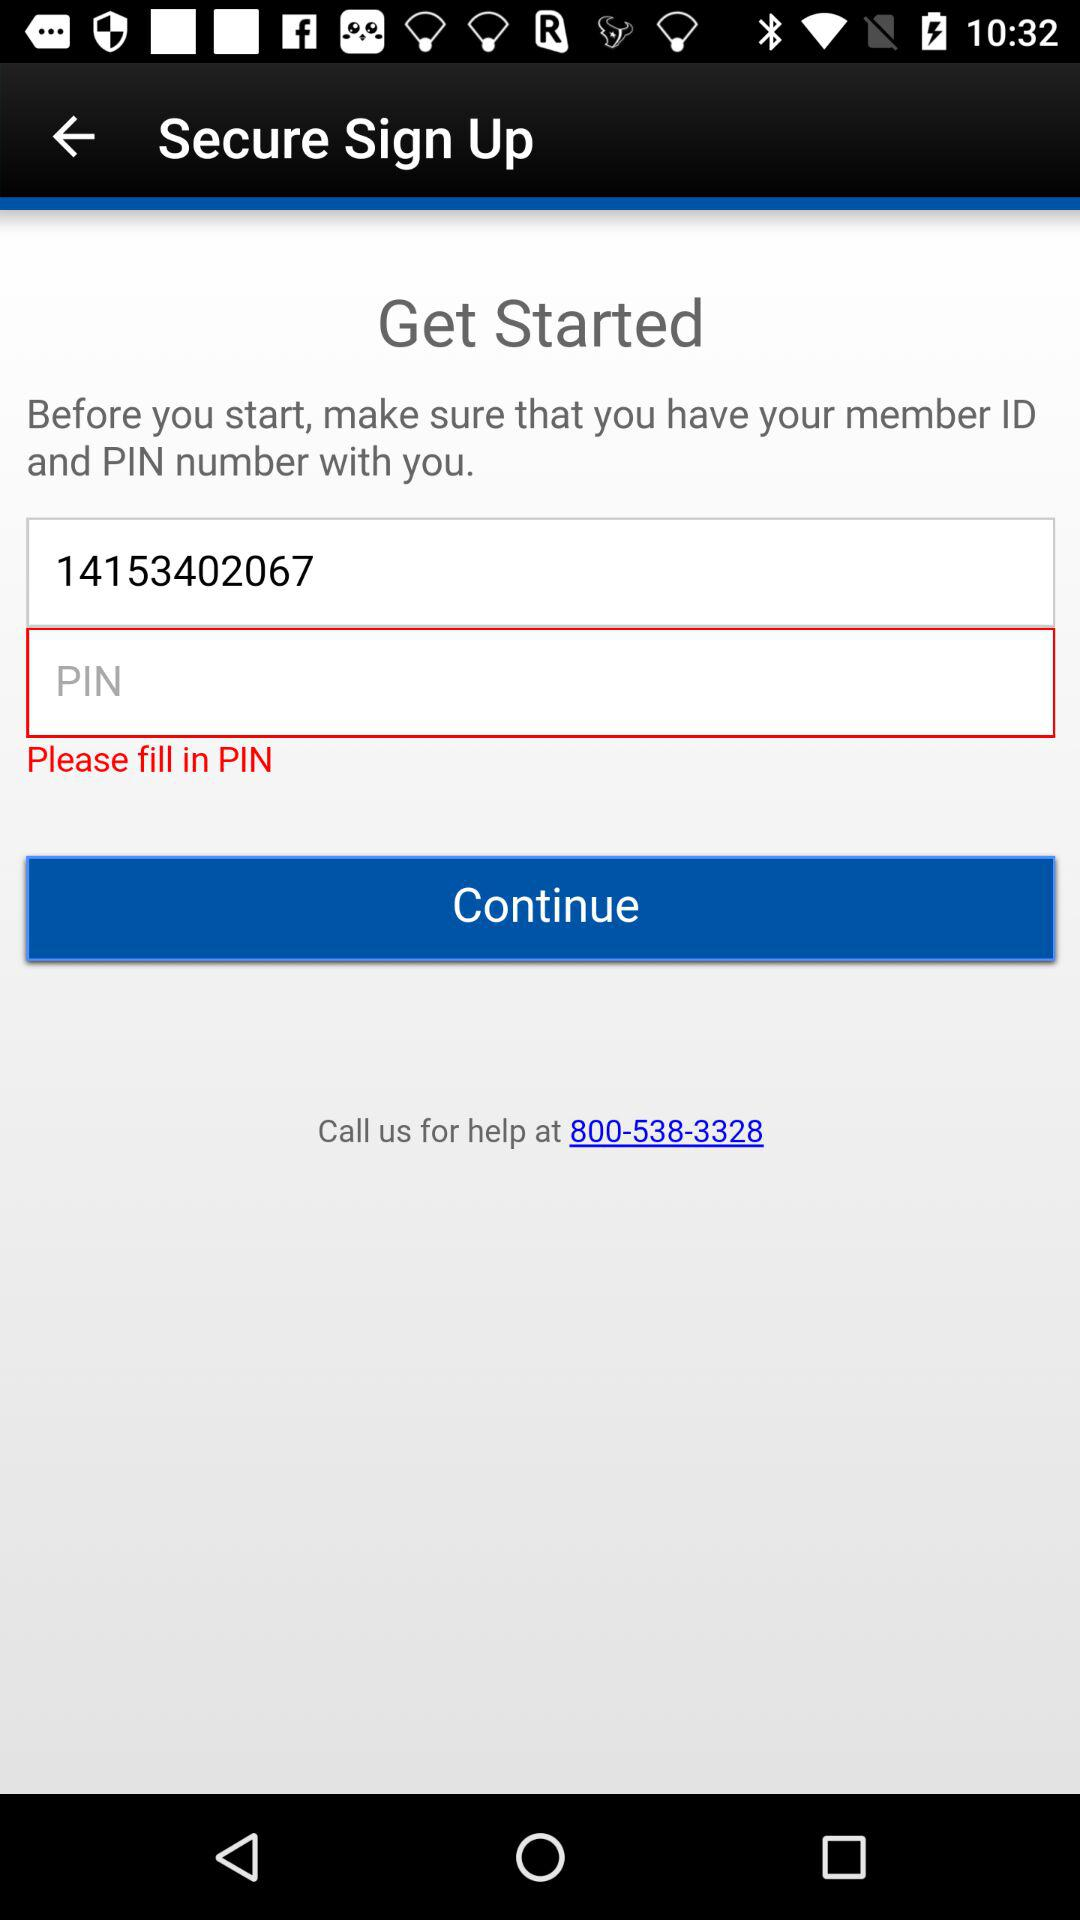What's the contact number for help? The contact number for help is 800-538-3328. 